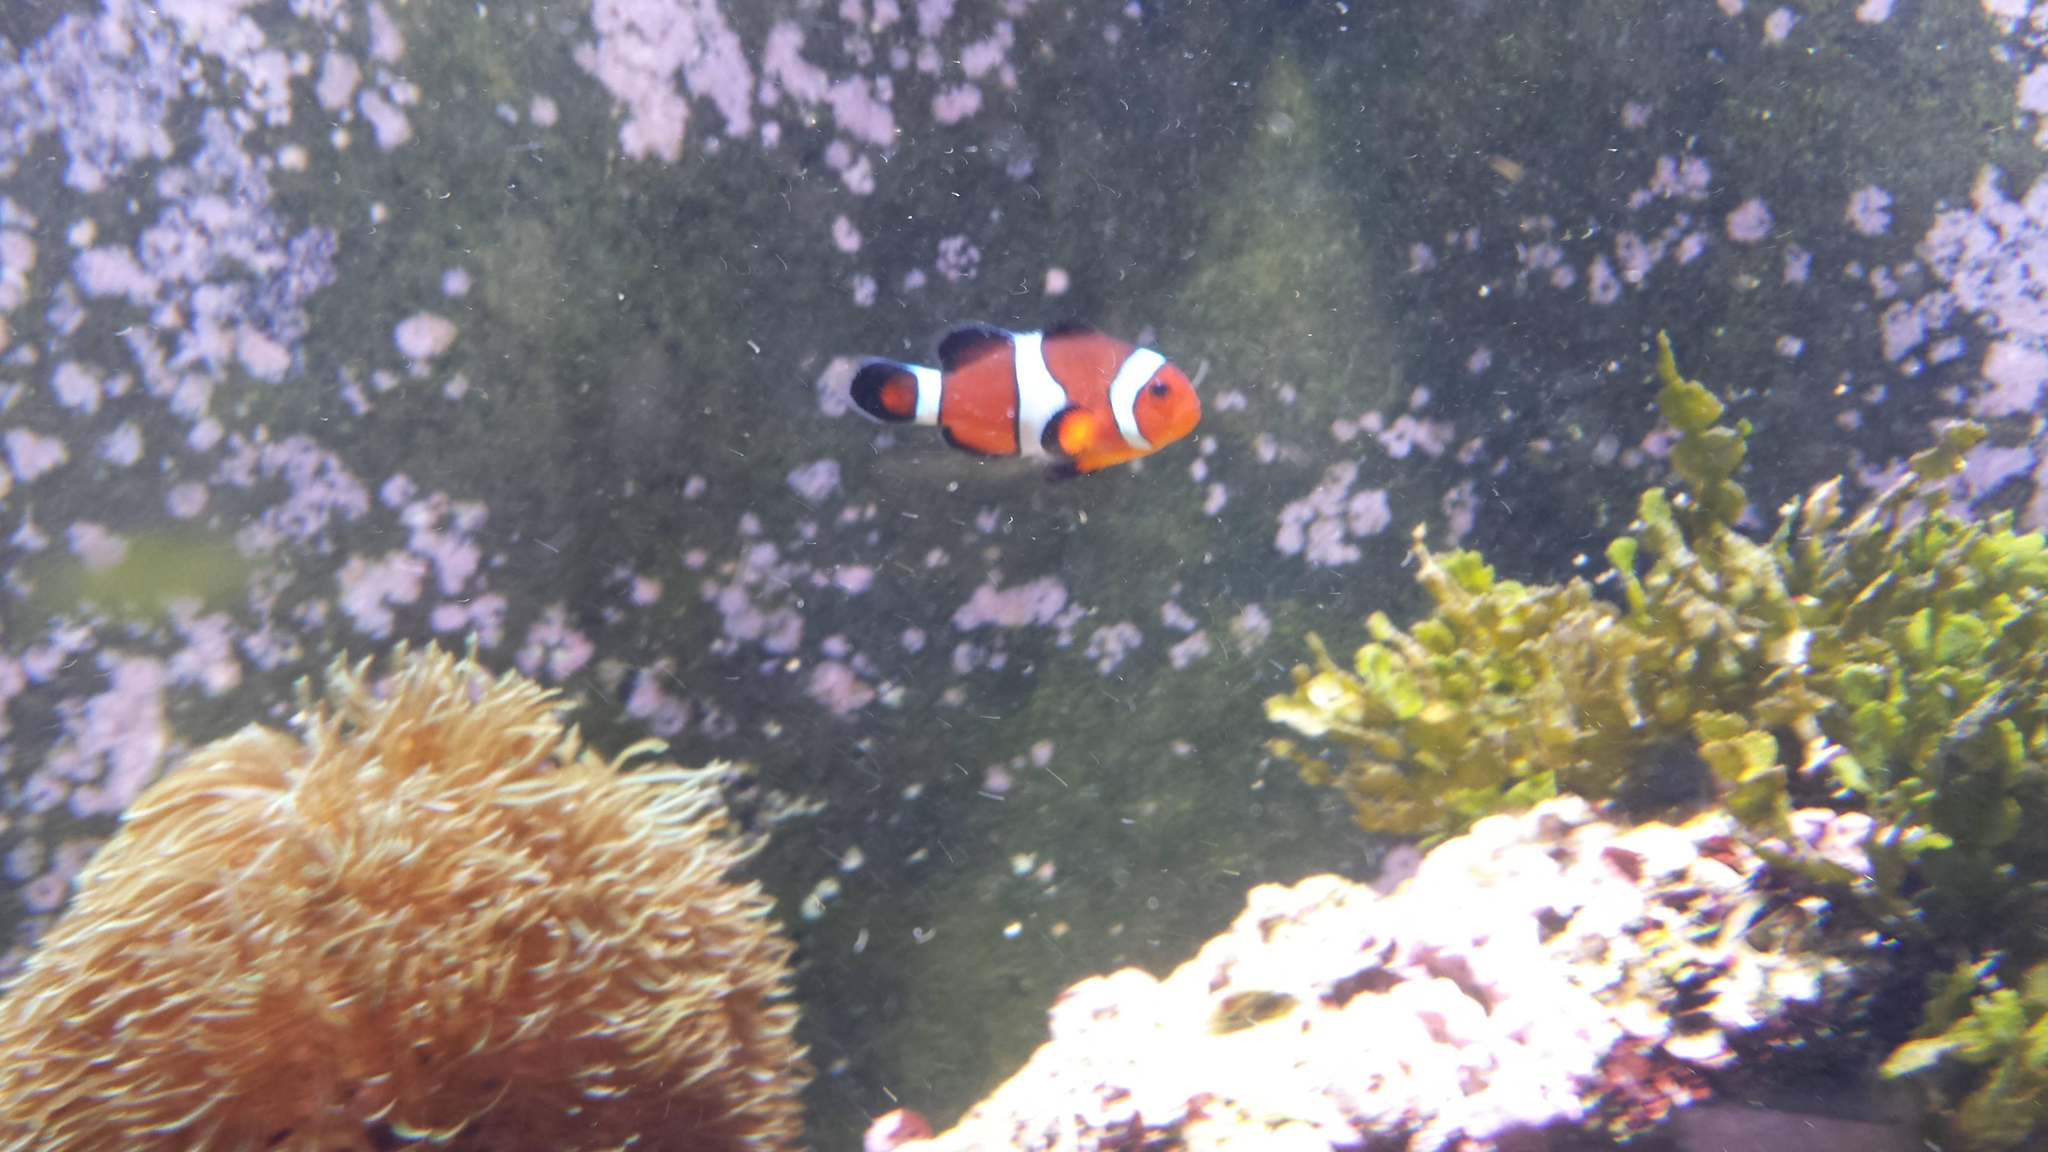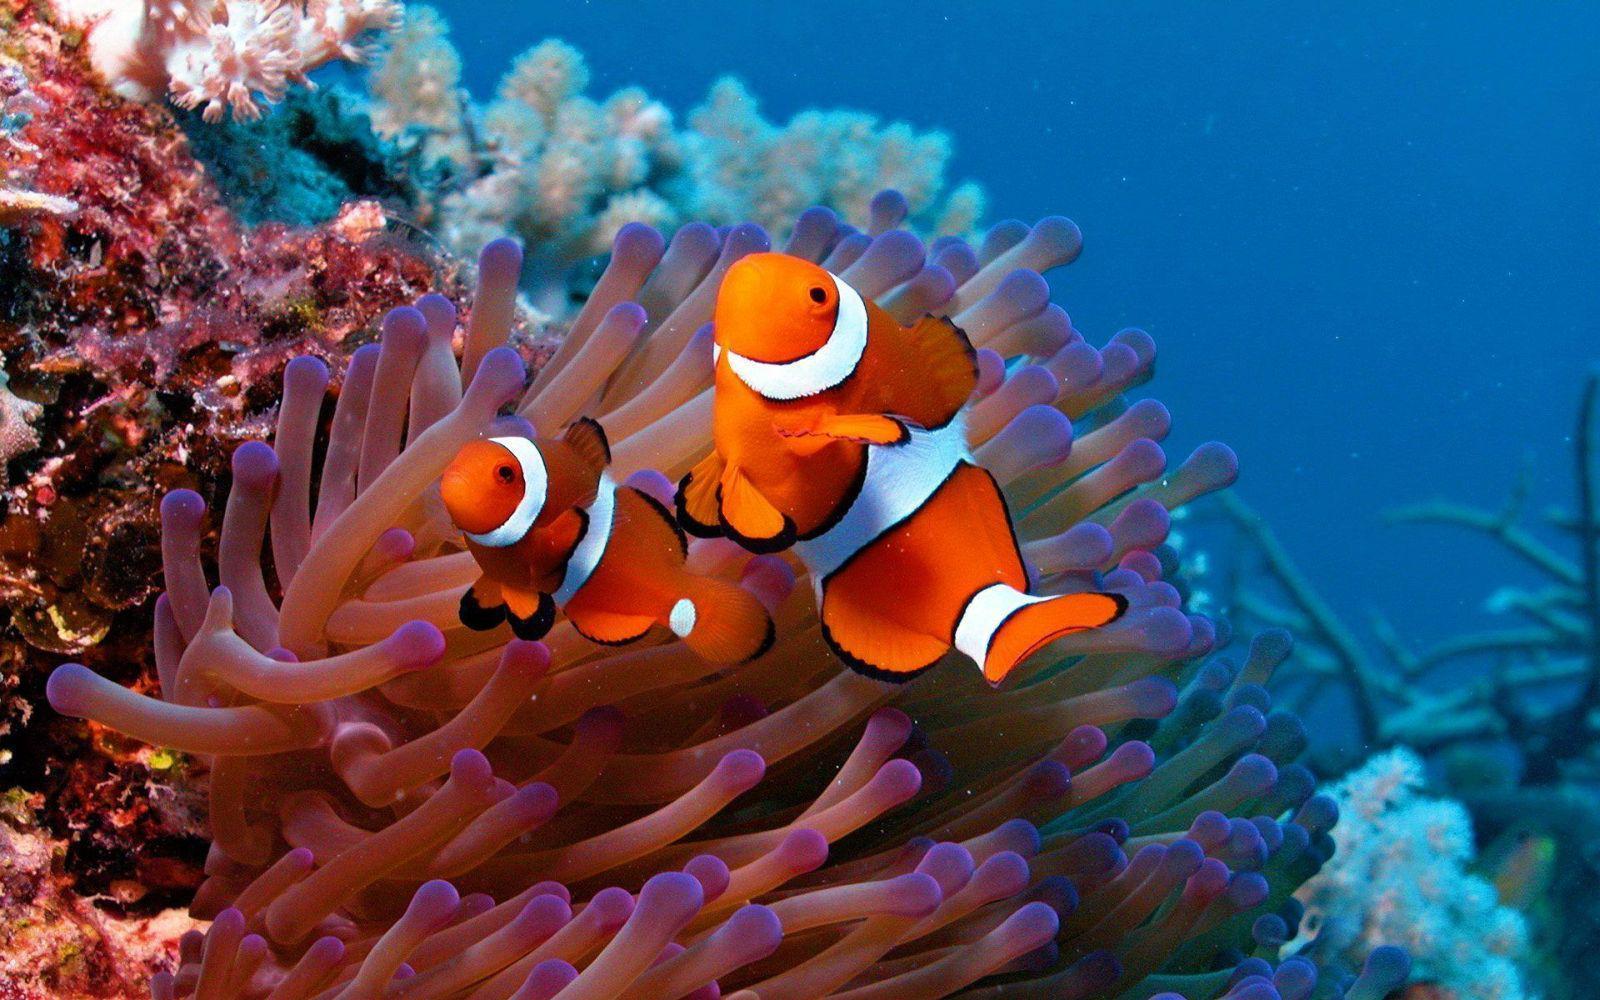The first image is the image on the left, the second image is the image on the right. Assess this claim about the two images: "An image includes two orange clownfish.". Correct or not? Answer yes or no. Yes. 